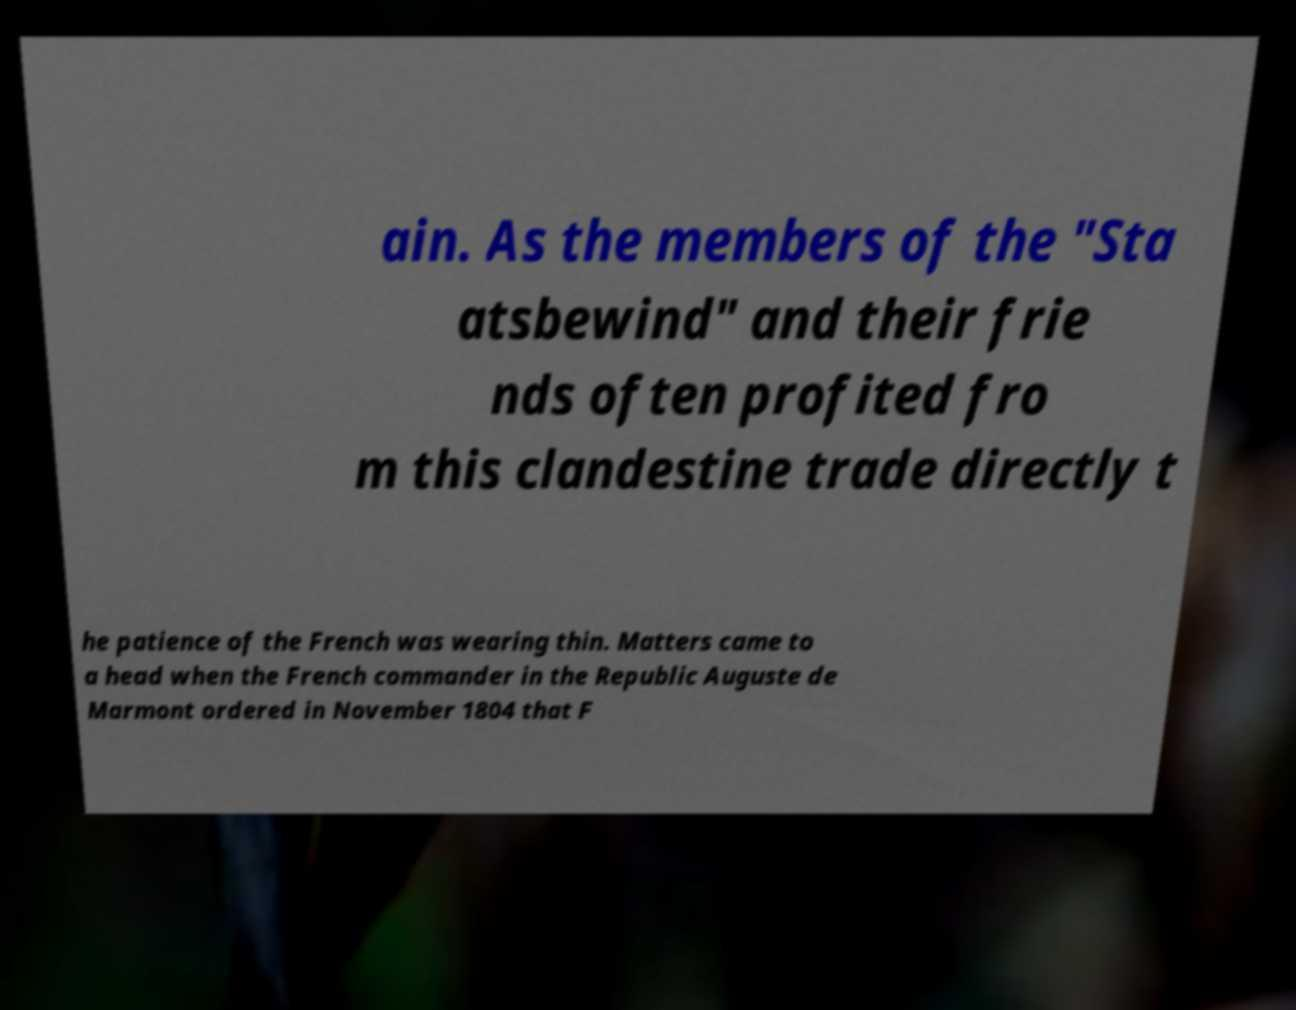There's text embedded in this image that I need extracted. Can you transcribe it verbatim? ain. As the members of the "Sta atsbewind" and their frie nds often profited fro m this clandestine trade directly t he patience of the French was wearing thin. Matters came to a head when the French commander in the Republic Auguste de Marmont ordered in November 1804 that F 